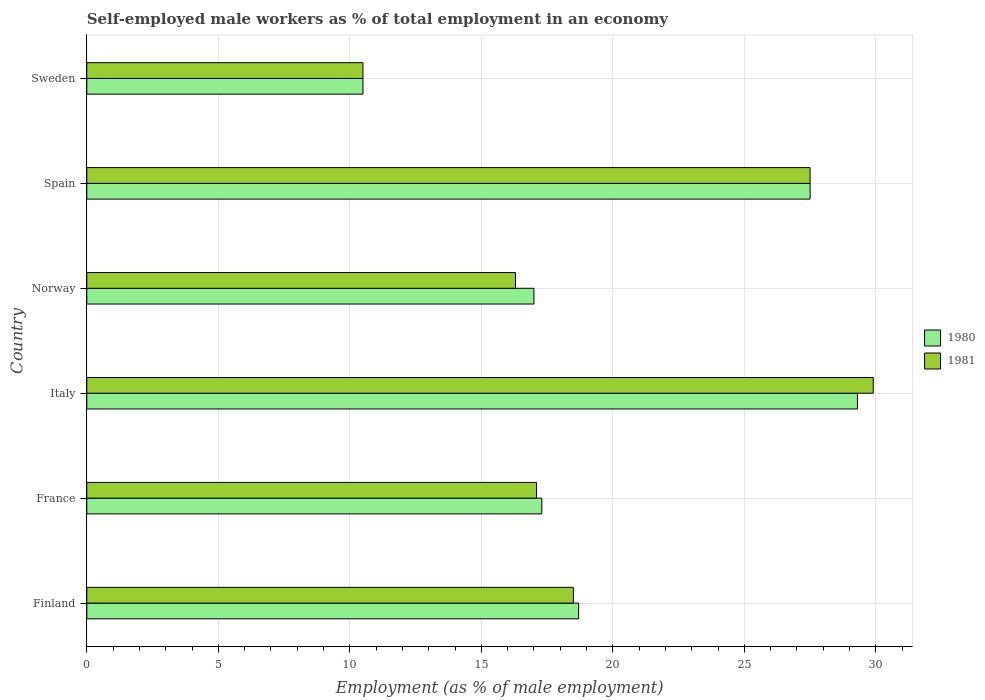Are the number of bars per tick equal to the number of legend labels?
Offer a terse response. Yes. How many bars are there on the 2nd tick from the top?
Give a very brief answer. 2. What is the label of the 4th group of bars from the top?
Your answer should be very brief. Italy. What is the percentage of self-employed male workers in 1980 in Italy?
Keep it short and to the point. 29.3. Across all countries, what is the maximum percentage of self-employed male workers in 1980?
Give a very brief answer. 29.3. Across all countries, what is the minimum percentage of self-employed male workers in 1981?
Your answer should be compact. 10.5. What is the total percentage of self-employed male workers in 1981 in the graph?
Your answer should be very brief. 119.8. What is the difference between the percentage of self-employed male workers in 1980 in France and that in Sweden?
Keep it short and to the point. 6.8. What is the average percentage of self-employed male workers in 1981 per country?
Keep it short and to the point. 19.97. What is the difference between the percentage of self-employed male workers in 1980 and percentage of self-employed male workers in 1981 in Finland?
Offer a very short reply. 0.2. What is the ratio of the percentage of self-employed male workers in 1980 in France to that in Italy?
Your answer should be very brief. 0.59. What is the difference between the highest and the second highest percentage of self-employed male workers in 1981?
Provide a short and direct response. 2.4. What is the difference between the highest and the lowest percentage of self-employed male workers in 1981?
Your answer should be very brief. 19.4. In how many countries, is the percentage of self-employed male workers in 1980 greater than the average percentage of self-employed male workers in 1980 taken over all countries?
Your answer should be compact. 2. Does the graph contain any zero values?
Provide a succinct answer. No. Where does the legend appear in the graph?
Keep it short and to the point. Center right. What is the title of the graph?
Your answer should be compact. Self-employed male workers as % of total employment in an economy. Does "1961" appear as one of the legend labels in the graph?
Ensure brevity in your answer.  No. What is the label or title of the X-axis?
Your answer should be compact. Employment (as % of male employment). What is the Employment (as % of male employment) in 1980 in Finland?
Provide a succinct answer. 18.7. What is the Employment (as % of male employment) of 1981 in Finland?
Ensure brevity in your answer.  18.5. What is the Employment (as % of male employment) in 1980 in France?
Your answer should be compact. 17.3. What is the Employment (as % of male employment) in 1981 in France?
Provide a succinct answer. 17.1. What is the Employment (as % of male employment) in 1980 in Italy?
Offer a very short reply. 29.3. What is the Employment (as % of male employment) of 1981 in Italy?
Offer a very short reply. 29.9. What is the Employment (as % of male employment) in 1981 in Norway?
Your answer should be compact. 16.3. What is the Employment (as % of male employment) in 1980 in Spain?
Provide a short and direct response. 27.5. What is the Employment (as % of male employment) of 1981 in Sweden?
Give a very brief answer. 10.5. Across all countries, what is the maximum Employment (as % of male employment) in 1980?
Offer a terse response. 29.3. Across all countries, what is the maximum Employment (as % of male employment) of 1981?
Offer a terse response. 29.9. Across all countries, what is the minimum Employment (as % of male employment) of 1980?
Your answer should be very brief. 10.5. What is the total Employment (as % of male employment) of 1980 in the graph?
Offer a terse response. 120.3. What is the total Employment (as % of male employment) of 1981 in the graph?
Your answer should be very brief. 119.8. What is the difference between the Employment (as % of male employment) in 1980 in Finland and that in France?
Make the answer very short. 1.4. What is the difference between the Employment (as % of male employment) in 1981 in Finland and that in France?
Keep it short and to the point. 1.4. What is the difference between the Employment (as % of male employment) in 1981 in Finland and that in Norway?
Your response must be concise. 2.2. What is the difference between the Employment (as % of male employment) of 1980 in Finland and that in Spain?
Offer a terse response. -8.8. What is the difference between the Employment (as % of male employment) in 1981 in Finland and that in Spain?
Offer a terse response. -9. What is the difference between the Employment (as % of male employment) of 1980 in Finland and that in Sweden?
Provide a short and direct response. 8.2. What is the difference between the Employment (as % of male employment) of 1981 in Finland and that in Sweden?
Your answer should be very brief. 8. What is the difference between the Employment (as % of male employment) in 1980 in France and that in Norway?
Provide a short and direct response. 0.3. What is the difference between the Employment (as % of male employment) of 1981 in France and that in Norway?
Your answer should be compact. 0.8. What is the difference between the Employment (as % of male employment) in 1981 in France and that in Spain?
Provide a succinct answer. -10.4. What is the difference between the Employment (as % of male employment) in 1980 in France and that in Sweden?
Offer a terse response. 6.8. What is the difference between the Employment (as % of male employment) of 1981 in France and that in Sweden?
Keep it short and to the point. 6.6. What is the difference between the Employment (as % of male employment) of 1981 in Italy and that in Sweden?
Your answer should be very brief. 19.4. What is the difference between the Employment (as % of male employment) of 1980 in Norway and that in Spain?
Your answer should be very brief. -10.5. What is the difference between the Employment (as % of male employment) of 1981 in Norway and that in Spain?
Your answer should be very brief. -11.2. What is the difference between the Employment (as % of male employment) of 1980 in Norway and that in Sweden?
Your answer should be very brief. 6.5. What is the difference between the Employment (as % of male employment) of 1980 in Spain and that in Sweden?
Provide a short and direct response. 17. What is the difference between the Employment (as % of male employment) in 1980 in Finland and the Employment (as % of male employment) in 1981 in Norway?
Your response must be concise. 2.4. What is the difference between the Employment (as % of male employment) in 1980 in Finland and the Employment (as % of male employment) in 1981 in Sweden?
Offer a very short reply. 8.2. What is the difference between the Employment (as % of male employment) in 1980 in France and the Employment (as % of male employment) in 1981 in Spain?
Offer a terse response. -10.2. What is the difference between the Employment (as % of male employment) in 1980 in Italy and the Employment (as % of male employment) in 1981 in Spain?
Give a very brief answer. 1.8. What is the difference between the Employment (as % of male employment) in 1980 in Spain and the Employment (as % of male employment) in 1981 in Sweden?
Make the answer very short. 17. What is the average Employment (as % of male employment) of 1980 per country?
Provide a succinct answer. 20.05. What is the average Employment (as % of male employment) in 1981 per country?
Offer a terse response. 19.97. What is the difference between the Employment (as % of male employment) in 1980 and Employment (as % of male employment) in 1981 in Norway?
Your response must be concise. 0.7. What is the ratio of the Employment (as % of male employment) in 1980 in Finland to that in France?
Your response must be concise. 1.08. What is the ratio of the Employment (as % of male employment) of 1981 in Finland to that in France?
Give a very brief answer. 1.08. What is the ratio of the Employment (as % of male employment) of 1980 in Finland to that in Italy?
Ensure brevity in your answer.  0.64. What is the ratio of the Employment (as % of male employment) in 1981 in Finland to that in Italy?
Your response must be concise. 0.62. What is the ratio of the Employment (as % of male employment) in 1981 in Finland to that in Norway?
Your response must be concise. 1.14. What is the ratio of the Employment (as % of male employment) of 1980 in Finland to that in Spain?
Your answer should be compact. 0.68. What is the ratio of the Employment (as % of male employment) of 1981 in Finland to that in Spain?
Make the answer very short. 0.67. What is the ratio of the Employment (as % of male employment) of 1980 in Finland to that in Sweden?
Your response must be concise. 1.78. What is the ratio of the Employment (as % of male employment) in 1981 in Finland to that in Sweden?
Give a very brief answer. 1.76. What is the ratio of the Employment (as % of male employment) of 1980 in France to that in Italy?
Make the answer very short. 0.59. What is the ratio of the Employment (as % of male employment) in 1981 in France to that in Italy?
Your answer should be very brief. 0.57. What is the ratio of the Employment (as % of male employment) of 1980 in France to that in Norway?
Offer a very short reply. 1.02. What is the ratio of the Employment (as % of male employment) of 1981 in France to that in Norway?
Your answer should be compact. 1.05. What is the ratio of the Employment (as % of male employment) in 1980 in France to that in Spain?
Offer a very short reply. 0.63. What is the ratio of the Employment (as % of male employment) in 1981 in France to that in Spain?
Your response must be concise. 0.62. What is the ratio of the Employment (as % of male employment) of 1980 in France to that in Sweden?
Make the answer very short. 1.65. What is the ratio of the Employment (as % of male employment) in 1981 in France to that in Sweden?
Give a very brief answer. 1.63. What is the ratio of the Employment (as % of male employment) of 1980 in Italy to that in Norway?
Your response must be concise. 1.72. What is the ratio of the Employment (as % of male employment) of 1981 in Italy to that in Norway?
Provide a succinct answer. 1.83. What is the ratio of the Employment (as % of male employment) in 1980 in Italy to that in Spain?
Provide a short and direct response. 1.07. What is the ratio of the Employment (as % of male employment) of 1981 in Italy to that in Spain?
Your answer should be very brief. 1.09. What is the ratio of the Employment (as % of male employment) of 1980 in Italy to that in Sweden?
Your answer should be very brief. 2.79. What is the ratio of the Employment (as % of male employment) in 1981 in Italy to that in Sweden?
Offer a terse response. 2.85. What is the ratio of the Employment (as % of male employment) in 1980 in Norway to that in Spain?
Provide a succinct answer. 0.62. What is the ratio of the Employment (as % of male employment) of 1981 in Norway to that in Spain?
Your answer should be compact. 0.59. What is the ratio of the Employment (as % of male employment) of 1980 in Norway to that in Sweden?
Make the answer very short. 1.62. What is the ratio of the Employment (as % of male employment) in 1981 in Norway to that in Sweden?
Ensure brevity in your answer.  1.55. What is the ratio of the Employment (as % of male employment) of 1980 in Spain to that in Sweden?
Your answer should be compact. 2.62. What is the ratio of the Employment (as % of male employment) of 1981 in Spain to that in Sweden?
Offer a terse response. 2.62. What is the difference between the highest and the second highest Employment (as % of male employment) of 1981?
Ensure brevity in your answer.  2.4. 